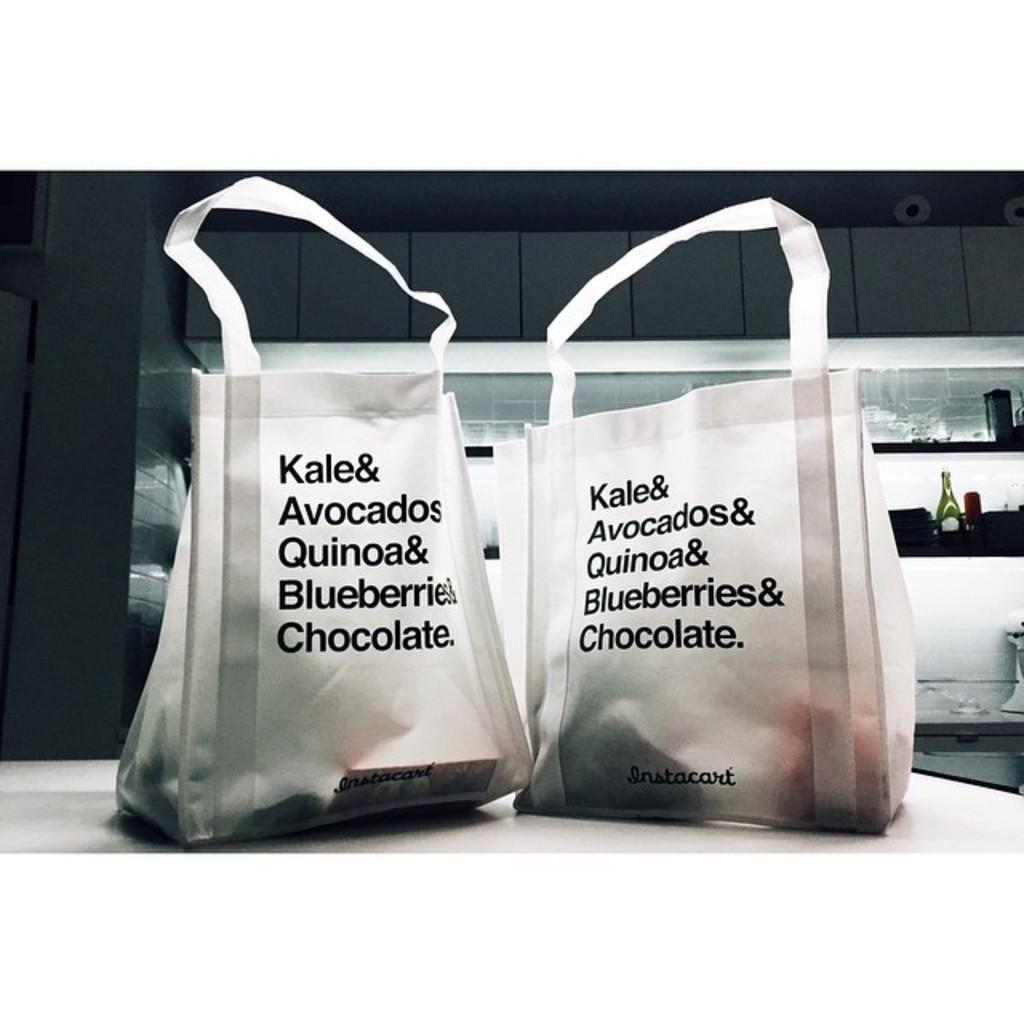What is the main piece of furniture in the image? There is a table in the image. What items are placed on the table? There are two carry bags on the table. What is written on the carry bags? The carry bags are labelled as 'kale & avocados'. What can be seen in the background of the image? There is a bottle and a shelf visible in the background of the image. What shape is the agreement between the kale and avocados in the image? There is no agreement between the kale and avocados in the image, as they are simply items in carry bags. How many mouths can be seen in the image? There are no mouths visible in the image. 